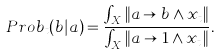<formula> <loc_0><loc_0><loc_500><loc_500>P r o b _ { t } ( b | a ) = \frac { \int _ { X } \| a \rightarrow b \wedge x _ { t } \| } { \int _ { X } \| a \rightarrow 1 \wedge x _ { t } \| } .</formula> 